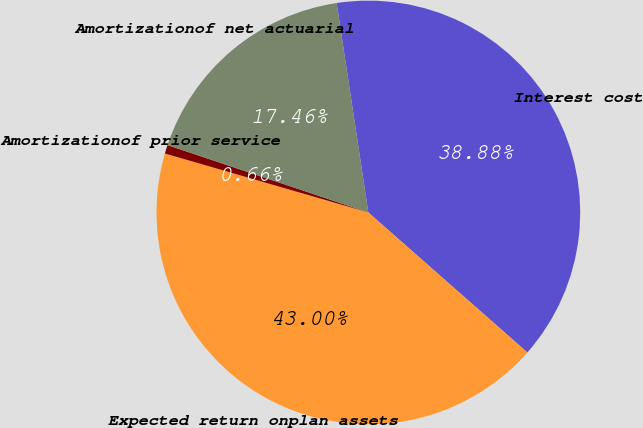Convert chart to OTSL. <chart><loc_0><loc_0><loc_500><loc_500><pie_chart><fcel>Interest cost<fcel>Expected return onplan assets<fcel>Amortizationof prior service<fcel>Amortizationof net actuarial<nl><fcel>38.88%<fcel>43.0%<fcel>0.66%<fcel>17.46%<nl></chart> 